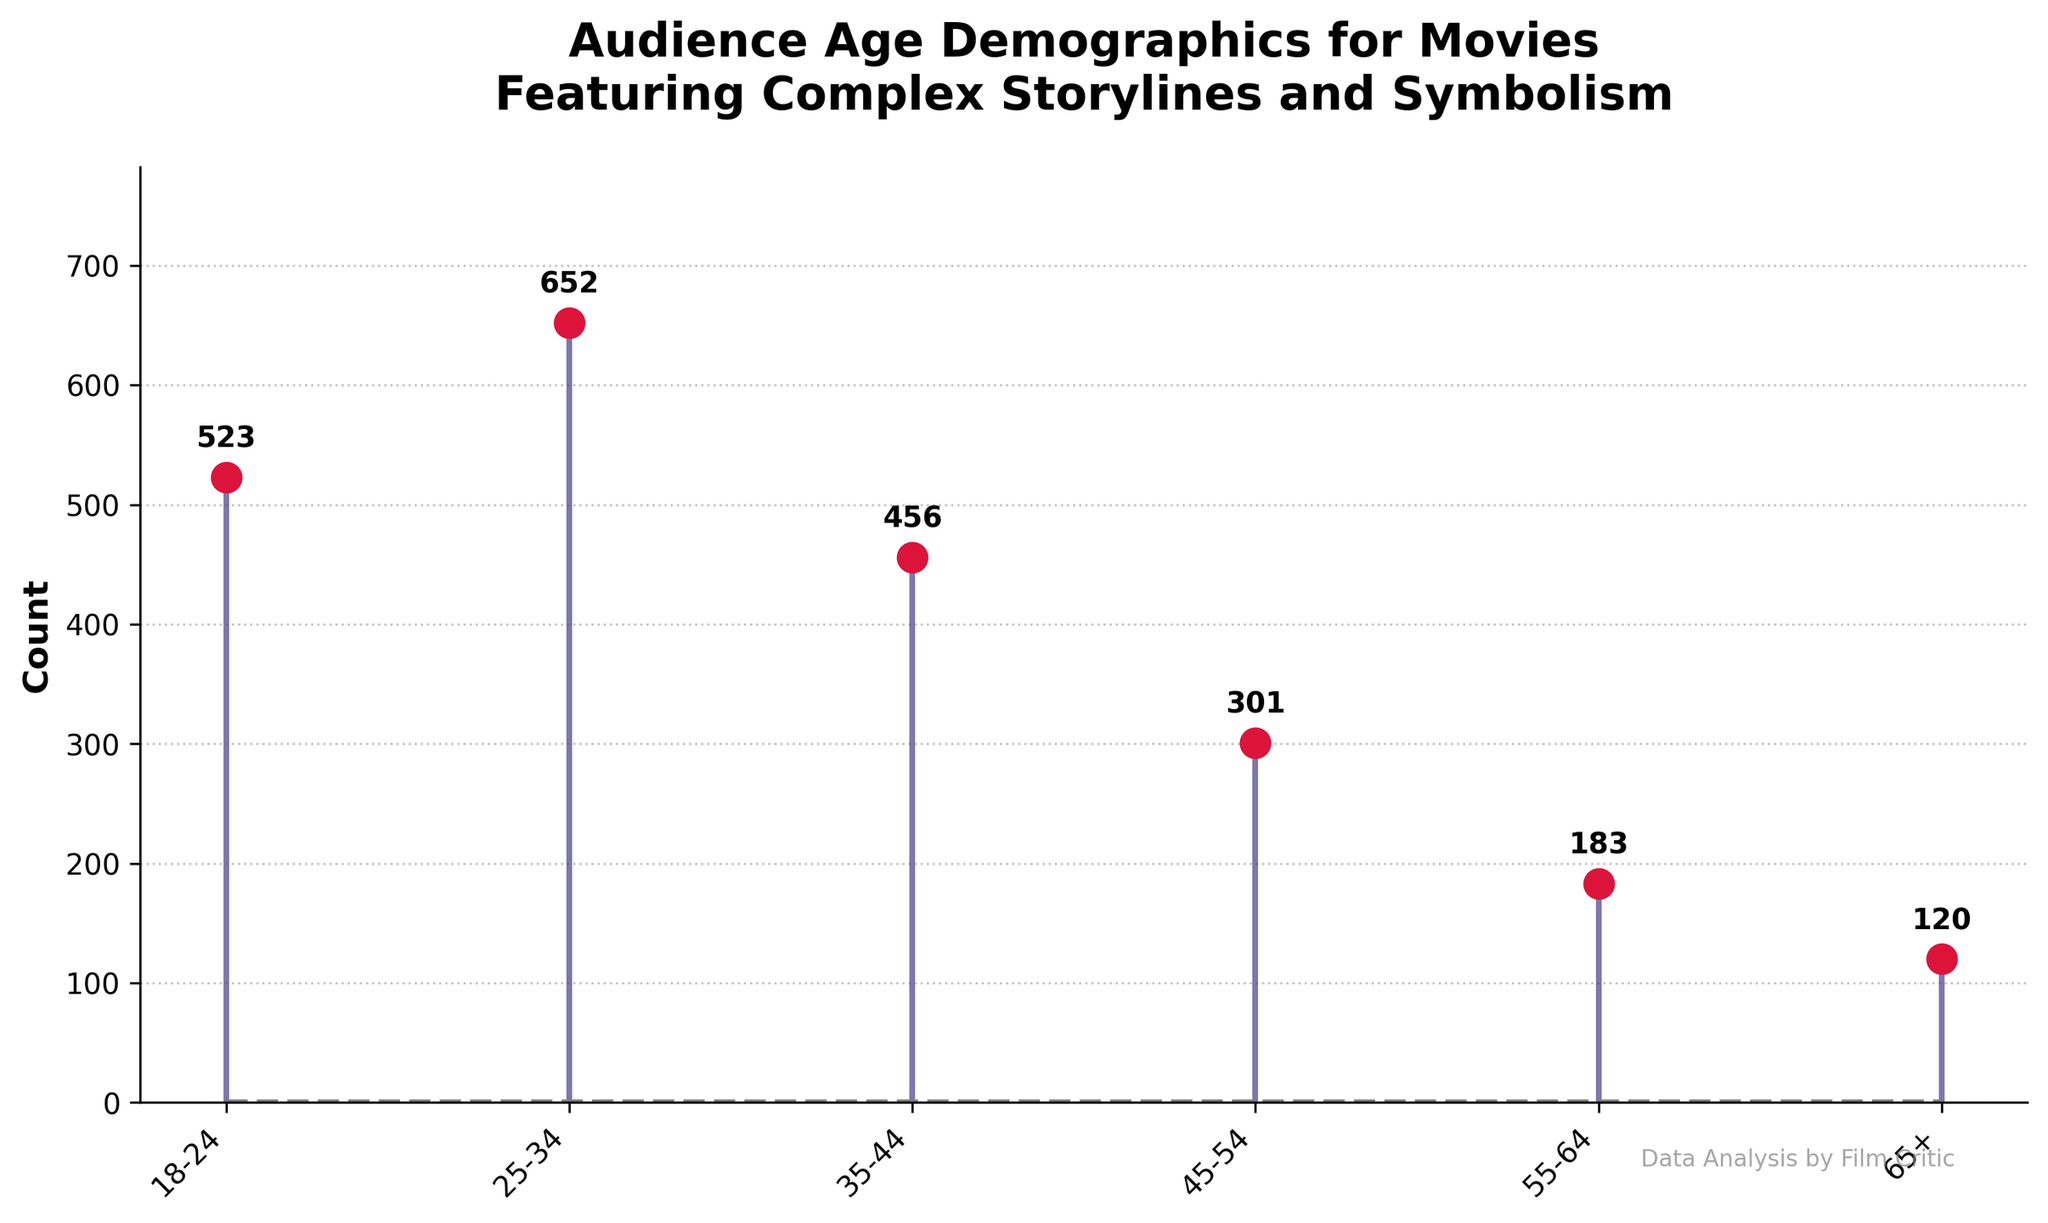what is the title of the plot? The title of the plot is located at the top of the figure and clearly states the focus of the analysis. The title reads "Audience Age Demographics for Movies Featuring Complex Storylines and Symbolism."
Answer: Audience Age Demographics for Movies Featuring Complex Storylines and Symbolism Which age group has the highest count? By observing the heights of the stems in the plot, the age group 25-34 has the highest count at 652, which is the tallest stem.
Answer: 25-34 What is the total count of all age groups combined? To calculate the total count, sum the values of all the age groups: 523 + 652 + 456 + 301 + 183 + 120 = 2235.
Answer: 2235 What are the lowest and highest counts, and which age groups have them? The lowest count is 120, belonging to the 65+ age group, and the highest count is 652, belonging to the 25-34 age group.
Answer: 120 (65+), 652 (25-34) How does the count for the 35-44 age group compare to the 45-54 age group? By comparing the heights of the stems, the 35-44 age group has a higher count (456) compared to the 45-54 age group (301).
Answer: 35-44 is greater What is the average count across all age groups? The average count is found by dividing the total count by the number of age groups: 2235 / 6 ≈ 372.5.
Answer: 372.5 How much more popular are movies with complex storylines among the 18-24 age group compared to the 65+ age group? The count for the 18-24 age group is 523, and for the 65+ age group is 120. The difference is 523 - 120 = 403.
Answer: 403 more Which two age groups have the closest counts? By examining the counts, the 18-24 and 35-44 age groups have the counts of 523 and 456, respectively, with a difference of 67, which is the smallest difference among neighboring values.
Answer: 18-24 and 35-44 Do all age groups show a gradual decrease in count moving from younger to older audiences? The counts generally decrease from 25-34 to 65+, but this is not consistent throughout as the 18-24 age group is not higher than 25-34 and 35-44 falls after 25-34.
Answer: No Is the count for the 25-34 age group more than double the count for the 55-64 age group? The count for the 25-34 age group is 652, and for the 55-64 age group is 183. Doubling 183 gives 366. Since 652 > 366, it is more than double.
Answer: Yes 